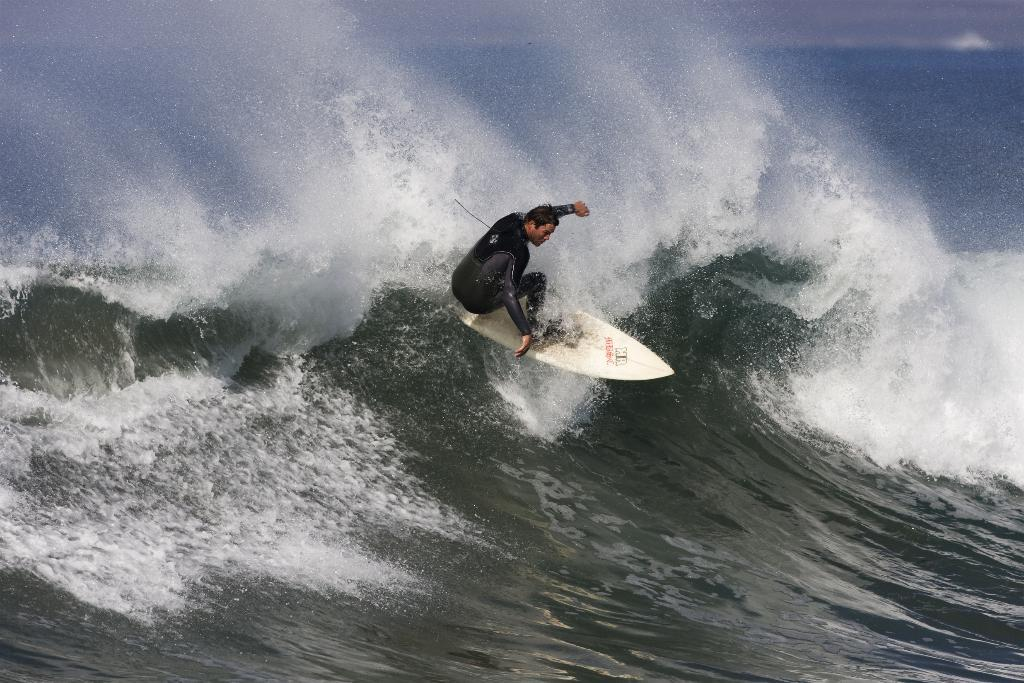Who is the person in the image? There is a man in the image. What is the man doing in the image? The man is surfing in the image. Where is the man surfing? The surfing is taking place on the sea. What type of yak can be seen in the image? There is no yak present in the image; it features a man surfing on the sea. How many beds are visible in the image? There are no beds present in the image. 